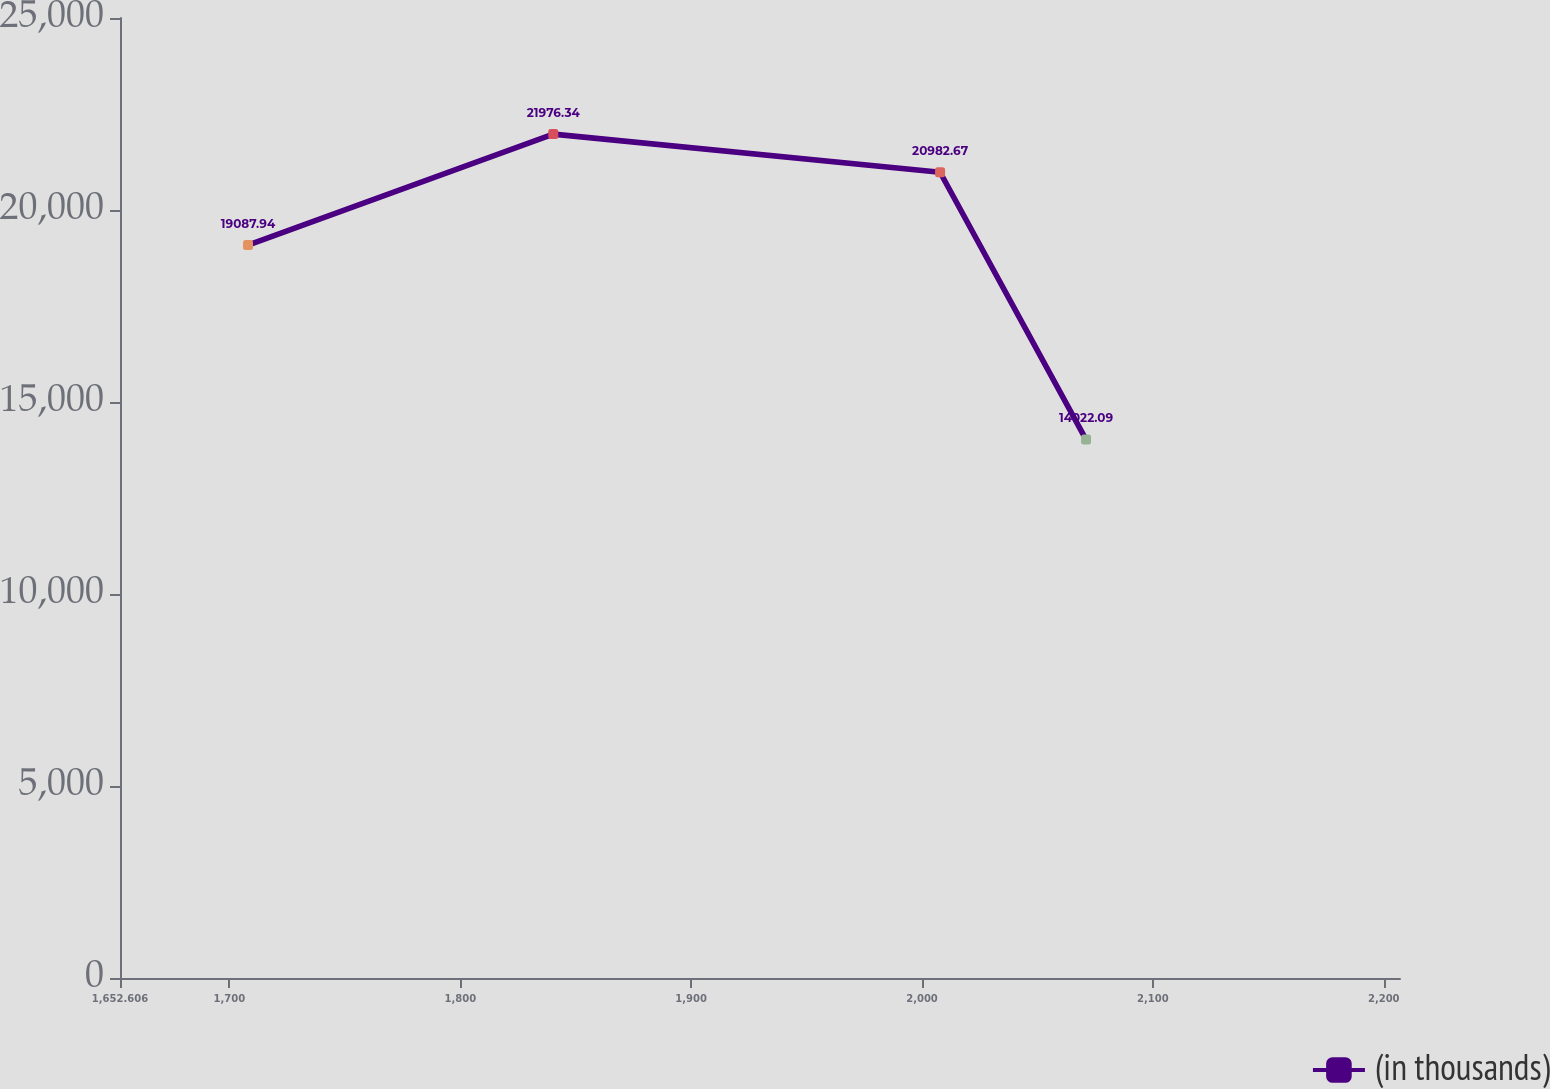<chart> <loc_0><loc_0><loc_500><loc_500><line_chart><ecel><fcel>(in thousands)<nl><fcel>1708.05<fcel>19087.9<nl><fcel>1840.28<fcel>21976.3<nl><fcel>2007.83<fcel>20982.7<nl><fcel>2071.06<fcel>14022.1<nl><fcel>2262.49<fcel>11694.4<nl></chart> 